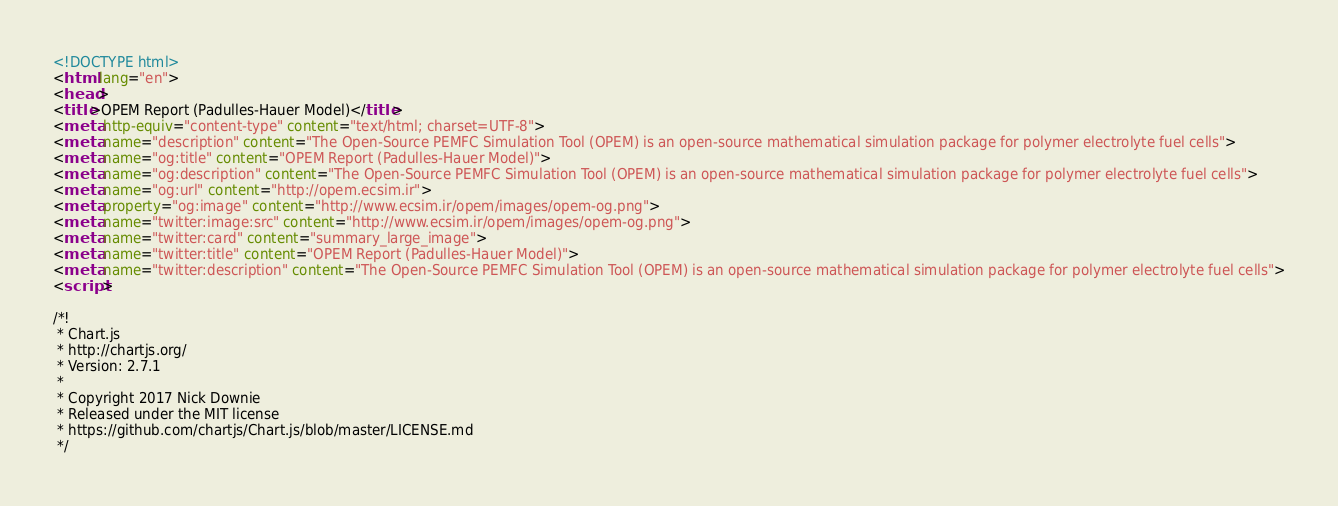<code> <loc_0><loc_0><loc_500><loc_500><_HTML_><!DOCTYPE html>
<html lang="en">
<head>
<title>OPEM Report (Padulles-Hauer Model)</title>
<meta http-equiv="content-type" content="text/html; charset=UTF-8">
<meta name="description" content="The Open-Source PEMFC Simulation Tool (OPEM) is an open-source mathematical simulation package for polymer electrolyte fuel cells">
<meta name="og:title" content="OPEM Report (Padulles-Hauer Model)">
<meta name="og:description" content="The Open-Source PEMFC Simulation Tool (OPEM) is an open-source mathematical simulation package for polymer electrolyte fuel cells">
<meta name="og:url" content="http://opem.ecsim.ir">
<meta property="og:image" content="http://www.ecsim.ir/opem/images/opem-og.png">
<meta name="twitter:image:src" content="http://www.ecsim.ir/opem/images/opem-og.png">
<meta name="twitter:card" content="summary_large_image">
<meta name="twitter:title" content="OPEM Report (Padulles-Hauer Model)">
<meta name="twitter:description" content="The Open-Source PEMFC Simulation Tool (OPEM) is an open-source mathematical simulation package for polymer electrolyte fuel cells">
<script>

/*!
 * Chart.js
 * http://chartjs.org/
 * Version: 2.7.1
 *
 * Copyright 2017 Nick Downie
 * Released under the MIT license
 * https://github.com/chartjs/Chart.js/blob/master/LICENSE.md
 */</code> 